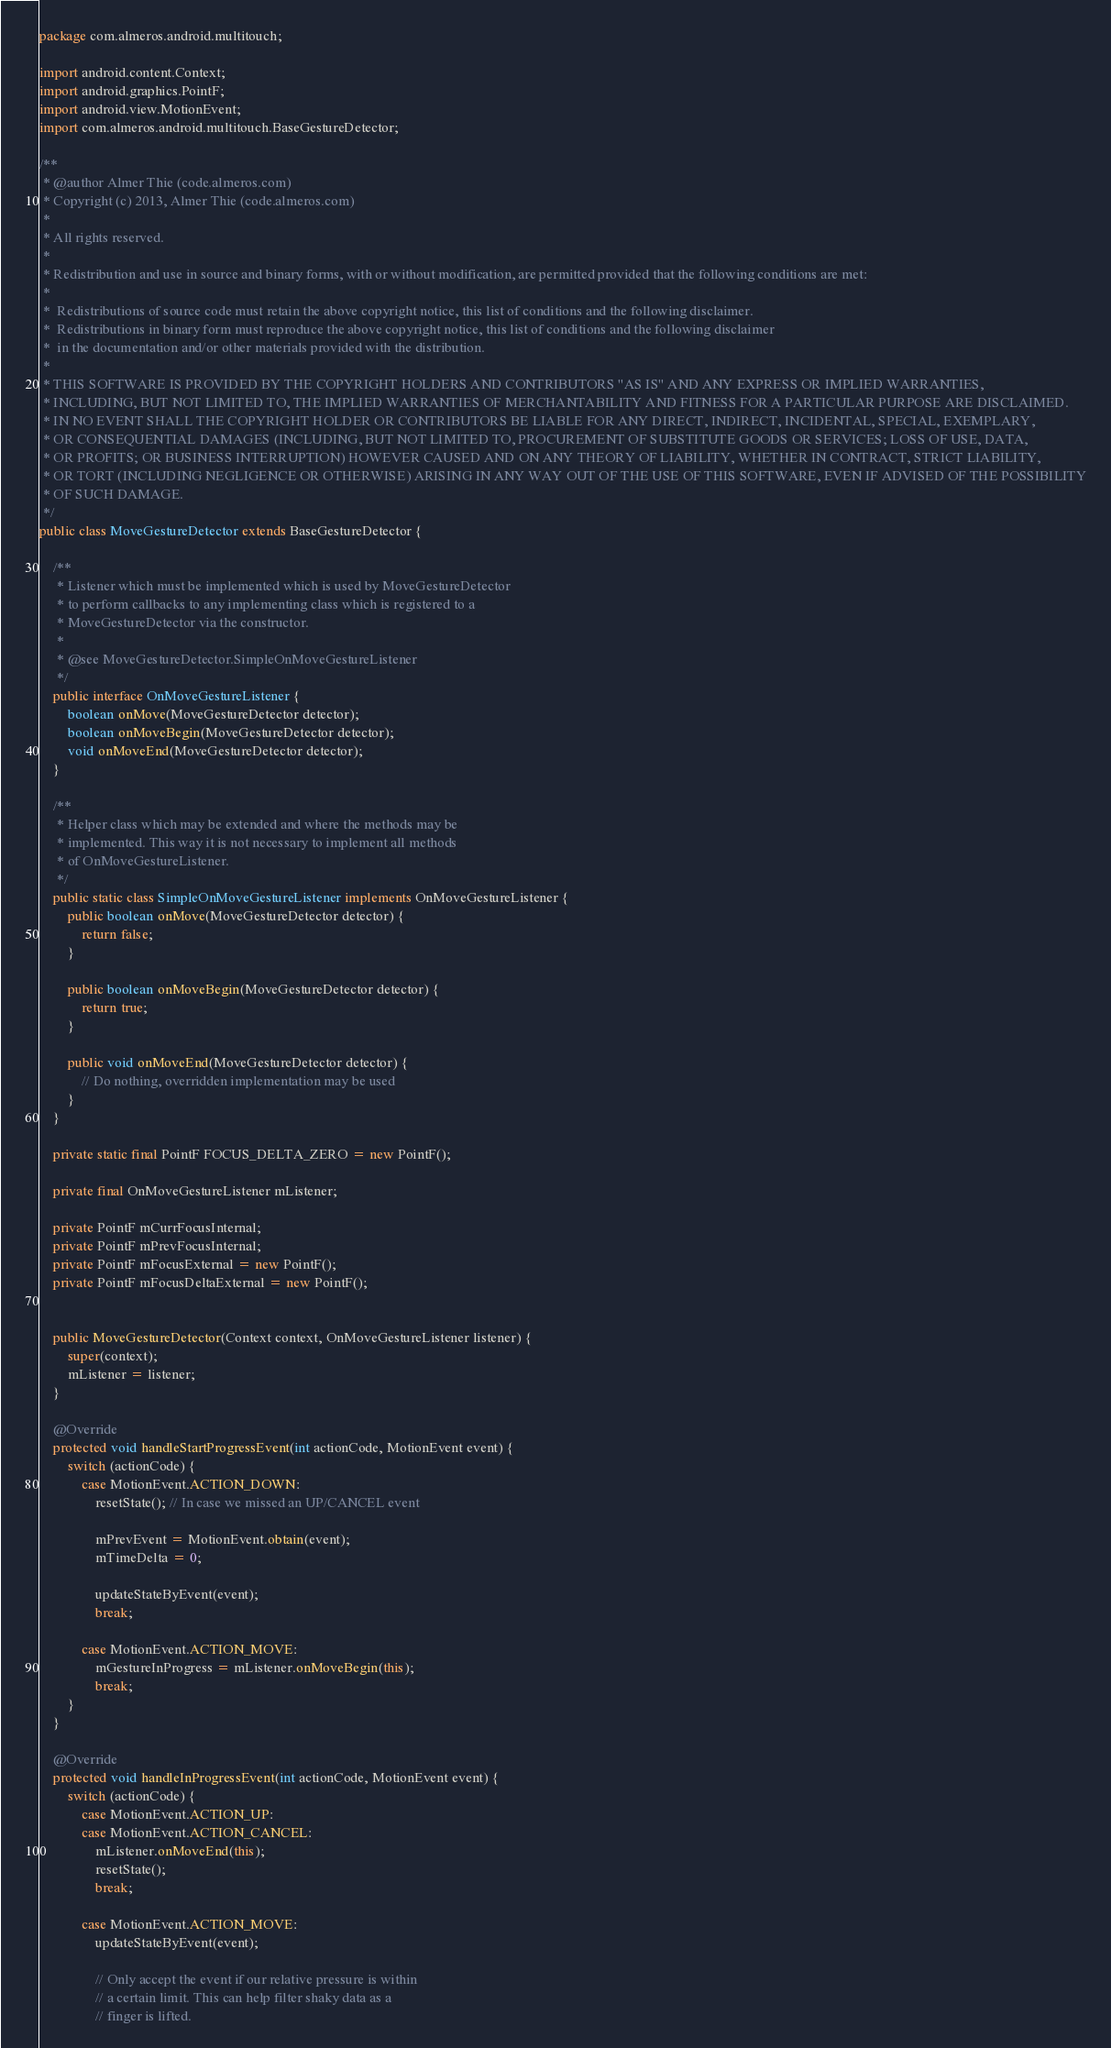<code> <loc_0><loc_0><loc_500><loc_500><_Java_>package com.almeros.android.multitouch;

import android.content.Context;
import android.graphics.PointF;
import android.view.MotionEvent;
import com.almeros.android.multitouch.BaseGestureDetector;

/**
 * @author Almer Thie (code.almeros.com)
 * Copyright (c) 2013, Almer Thie (code.almeros.com)
 *
 * All rights reserved.
 *
 * Redistribution and use in source and binary forms, with or without modification, are permitted provided that the following conditions are met:
 *
 *  Redistributions of source code must retain the above copyright notice, this list of conditions and the following disclaimer.
 *  Redistributions in binary form must reproduce the above copyright notice, this list of conditions and the following disclaimer
 *  in the documentation and/or other materials provided with the distribution.
 *
 * THIS SOFTWARE IS PROVIDED BY THE COPYRIGHT HOLDERS AND CONTRIBUTORS "AS IS" AND ANY EXPRESS OR IMPLIED WARRANTIES,
 * INCLUDING, BUT NOT LIMITED TO, THE IMPLIED WARRANTIES OF MERCHANTABILITY AND FITNESS FOR A PARTICULAR PURPOSE ARE DISCLAIMED.
 * IN NO EVENT SHALL THE COPYRIGHT HOLDER OR CONTRIBUTORS BE LIABLE FOR ANY DIRECT, INDIRECT, INCIDENTAL, SPECIAL, EXEMPLARY,
 * OR CONSEQUENTIAL DAMAGES (INCLUDING, BUT NOT LIMITED TO, PROCUREMENT OF SUBSTITUTE GOODS OR SERVICES; LOSS OF USE, DATA,
 * OR PROFITS; OR BUSINESS INTERRUPTION) HOWEVER CAUSED AND ON ANY THEORY OF LIABILITY, WHETHER IN CONTRACT, STRICT LIABILITY,
 * OR TORT (INCLUDING NEGLIGENCE OR OTHERWISE) ARISING IN ANY WAY OUT OF THE USE OF THIS SOFTWARE, EVEN IF ADVISED OF THE POSSIBILITY
 * OF SUCH DAMAGE.
 */
public class MoveGestureDetector extends BaseGestureDetector {

    /**
     * Listener which must be implemented which is used by MoveGestureDetector
     * to perform callbacks to any implementing class which is registered to a
     * MoveGestureDetector via the constructor.
     *
     * @see MoveGestureDetector.SimpleOnMoveGestureListener
     */
    public interface OnMoveGestureListener {
        boolean onMove(MoveGestureDetector detector);
        boolean onMoveBegin(MoveGestureDetector detector);
        void onMoveEnd(MoveGestureDetector detector);
    }

    /**
     * Helper class which may be extended and where the methods may be
     * implemented. This way it is not necessary to implement all methods
     * of OnMoveGestureListener.
     */
    public static class SimpleOnMoveGestureListener implements OnMoveGestureListener {
        public boolean onMove(MoveGestureDetector detector) {
            return false;
        }

        public boolean onMoveBegin(MoveGestureDetector detector) {
            return true;
        }

        public void onMoveEnd(MoveGestureDetector detector) {
            // Do nothing, overridden implementation may be used
        }
    }

    private static final PointF FOCUS_DELTA_ZERO = new PointF();

    private final OnMoveGestureListener mListener;

    private PointF mCurrFocusInternal;
    private PointF mPrevFocusInternal;
    private PointF mFocusExternal = new PointF();
    private PointF mFocusDeltaExternal = new PointF();


    public MoveGestureDetector(Context context, OnMoveGestureListener listener) {
        super(context);
        mListener = listener;
    }

    @Override
    protected void handleStartProgressEvent(int actionCode, MotionEvent event) {
        switch (actionCode) {
            case MotionEvent.ACTION_DOWN:
                resetState(); // In case we missed an UP/CANCEL event

                mPrevEvent = MotionEvent.obtain(event);
                mTimeDelta = 0;

                updateStateByEvent(event);
                break;

            case MotionEvent.ACTION_MOVE:
                mGestureInProgress = mListener.onMoveBegin(this);
                break;
        }
    }

    @Override
    protected void handleInProgressEvent(int actionCode, MotionEvent event) {
        switch (actionCode) {
            case MotionEvent.ACTION_UP:
            case MotionEvent.ACTION_CANCEL:
                mListener.onMoveEnd(this);
                resetState();
                break;

            case MotionEvent.ACTION_MOVE:
                updateStateByEvent(event);

                // Only accept the event if our relative pressure is within
                // a certain limit. This can help filter shaky data as a
                // finger is lifted.</code> 